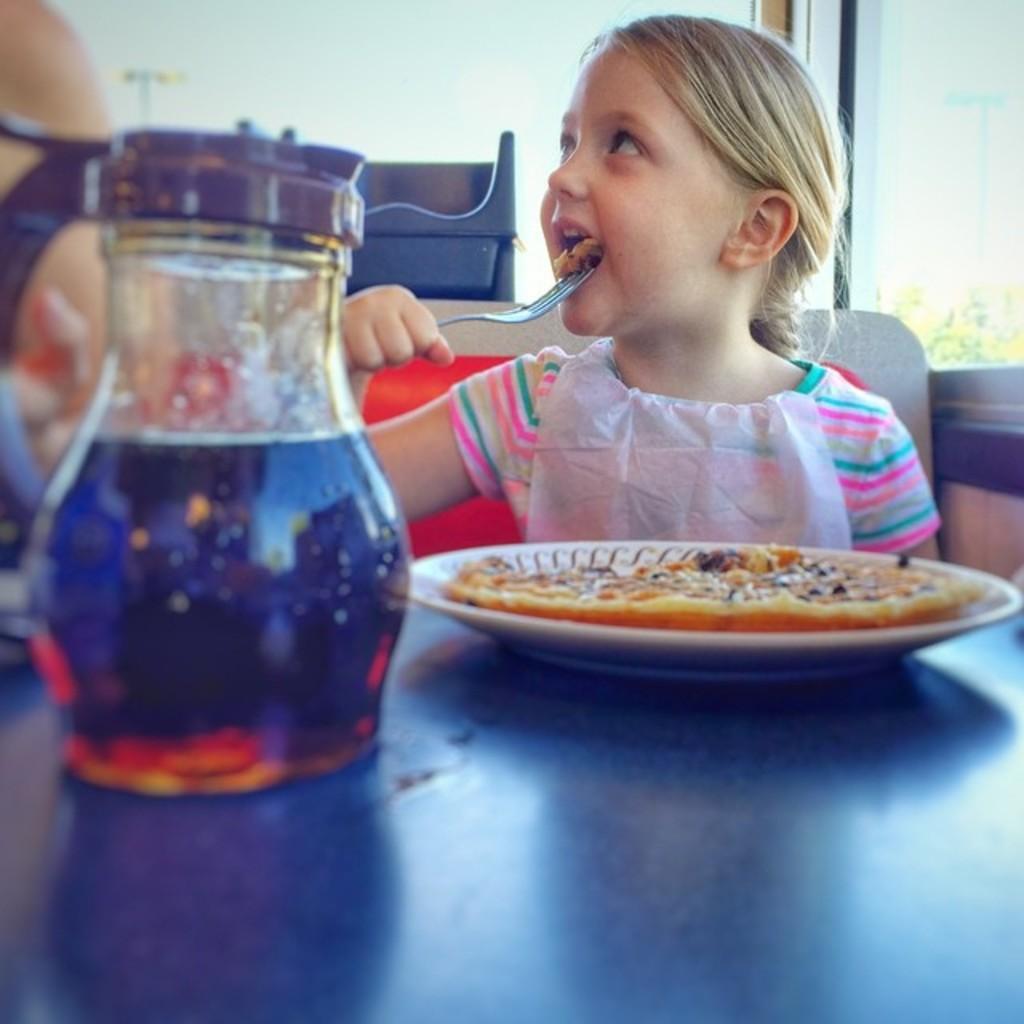Could you give a brief overview of what you see in this image? In this image I can see a girl is sitting. I can see she is holding a fork. Here I can see a jar, a white colour plate and in it I can see food. 